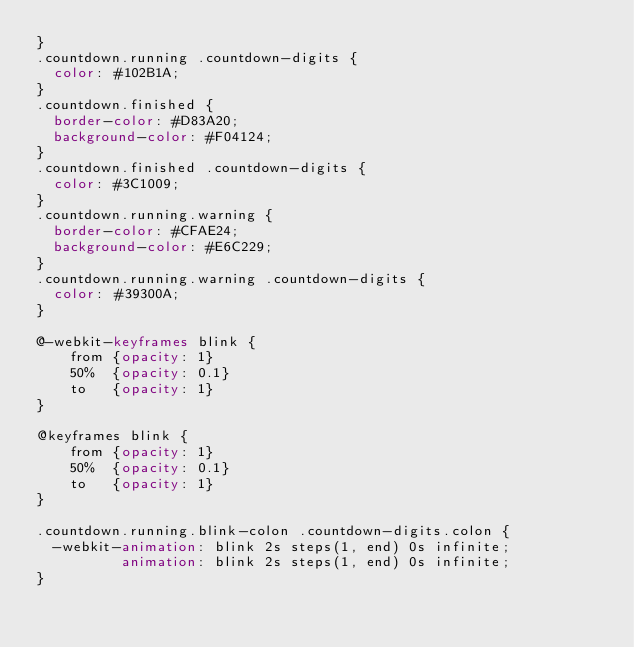Convert code to text. <code><loc_0><loc_0><loc_500><loc_500><_CSS_>}
.countdown.running .countdown-digits {
  color: #102B1A;
}
.countdown.finished {
  border-color: #D83A20;
  background-color: #F04124;
}
.countdown.finished .countdown-digits {
  color: #3C1009;
}
.countdown.running.warning {
  border-color: #CFAE24;
  background-color: #E6C229;
}
.countdown.running.warning .countdown-digits {
  color: #39300A;
}

@-webkit-keyframes blink {
	from {opacity: 1}
	50%  {opacity: 0.1}
	to   {opacity: 1}
}

@keyframes blink {
	from {opacity: 1}
	50%  {opacity: 0.1}
	to   {opacity: 1}
}

.countdown.running.blink-colon .countdown-digits.colon {
  -webkit-animation: blink 2s steps(1, end) 0s infinite;
          animation: blink 2s steps(1, end) 0s infinite;
}
</code> 